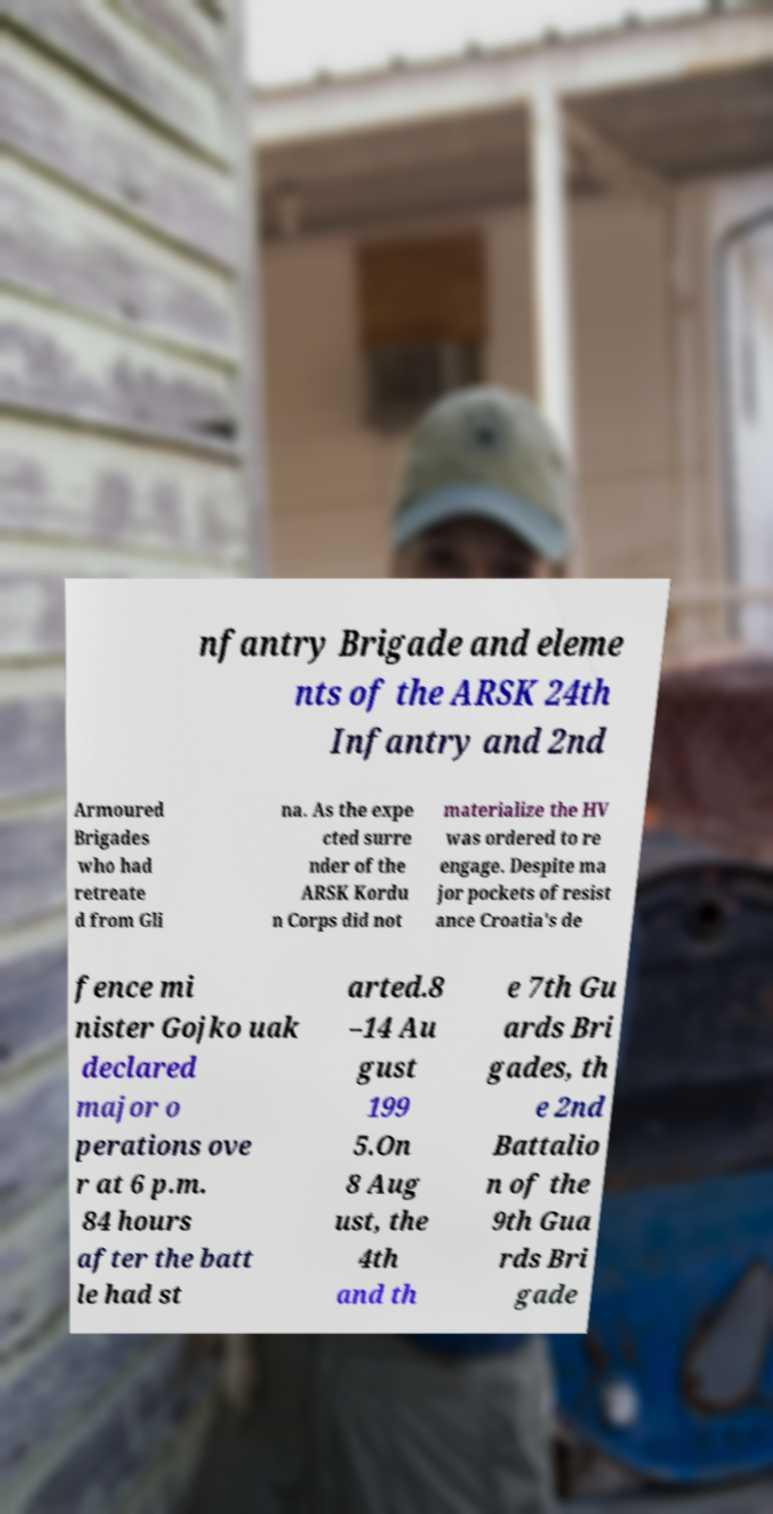Could you assist in decoding the text presented in this image and type it out clearly? nfantry Brigade and eleme nts of the ARSK 24th Infantry and 2nd Armoured Brigades who had retreate d from Gli na. As the expe cted surre nder of the ARSK Kordu n Corps did not materialize the HV was ordered to re engage. Despite ma jor pockets of resist ance Croatia's de fence mi nister Gojko uak declared major o perations ove r at 6 p.m. 84 hours after the batt le had st arted.8 –14 Au gust 199 5.On 8 Aug ust, the 4th and th e 7th Gu ards Bri gades, th e 2nd Battalio n of the 9th Gua rds Bri gade 